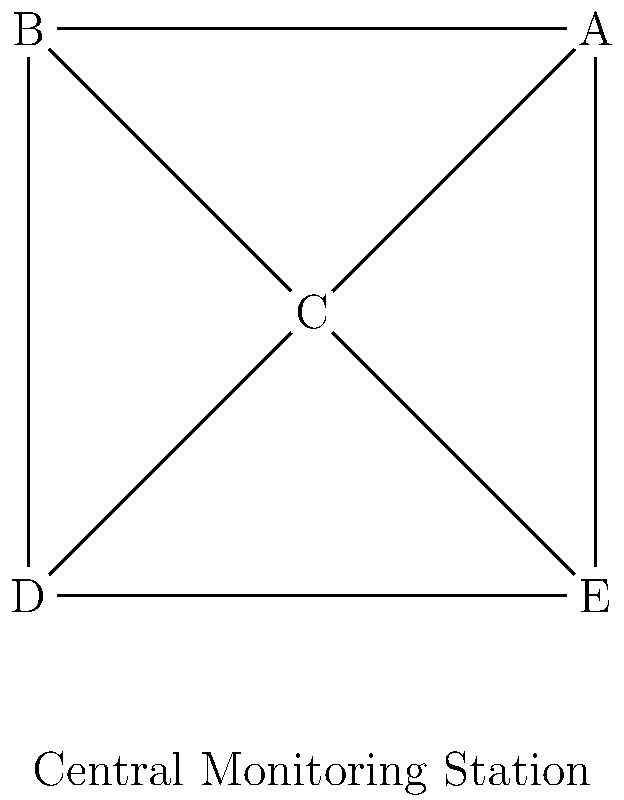In the network topology shown above for connecting various paranormal detection devices to a central monitoring station, which type of topology is depicted, and what is the maximum number of devices that would need to fail for the entire network to become disconnected? To answer this question, let's analyze the network topology step by step:

1. Identify the topology:
   - The diagram shows a central node (C) connected to all other nodes.
   - The outer nodes (A, B, D, E) are also connected to their adjacent nodes in a ring-like structure.
   - This combination of central connection and outer ring is known as a Hybrid Star-Ring topology.

2. Analyze the connections:
   - The central node (C) is connected to all other nodes (A, B, D, E).
   - Each outer node is connected to the central node and two adjacent nodes.

3. Determine the network's resilience:
   - If the central node (C) fails, the outer nodes can still communicate through the ring structure.
   - If any single outer node fails, the remaining nodes can still communicate through the central node and the ring.

4. Calculate the maximum number of device failures for network disconnection:
   - To disconnect the network, we need to break both the star and ring structures.
   - The minimum way to achieve this is by removing the central node (C) and any one outer node.

Therefore, the maximum number of devices that would need to fail for the entire network to become disconnected is 2: the central node and any one outer node.
Answer: Hybrid Star-Ring topology; 2 devices 